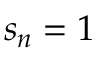Convert formula to latex. <formula><loc_0><loc_0><loc_500><loc_500>s _ { n } = 1</formula> 